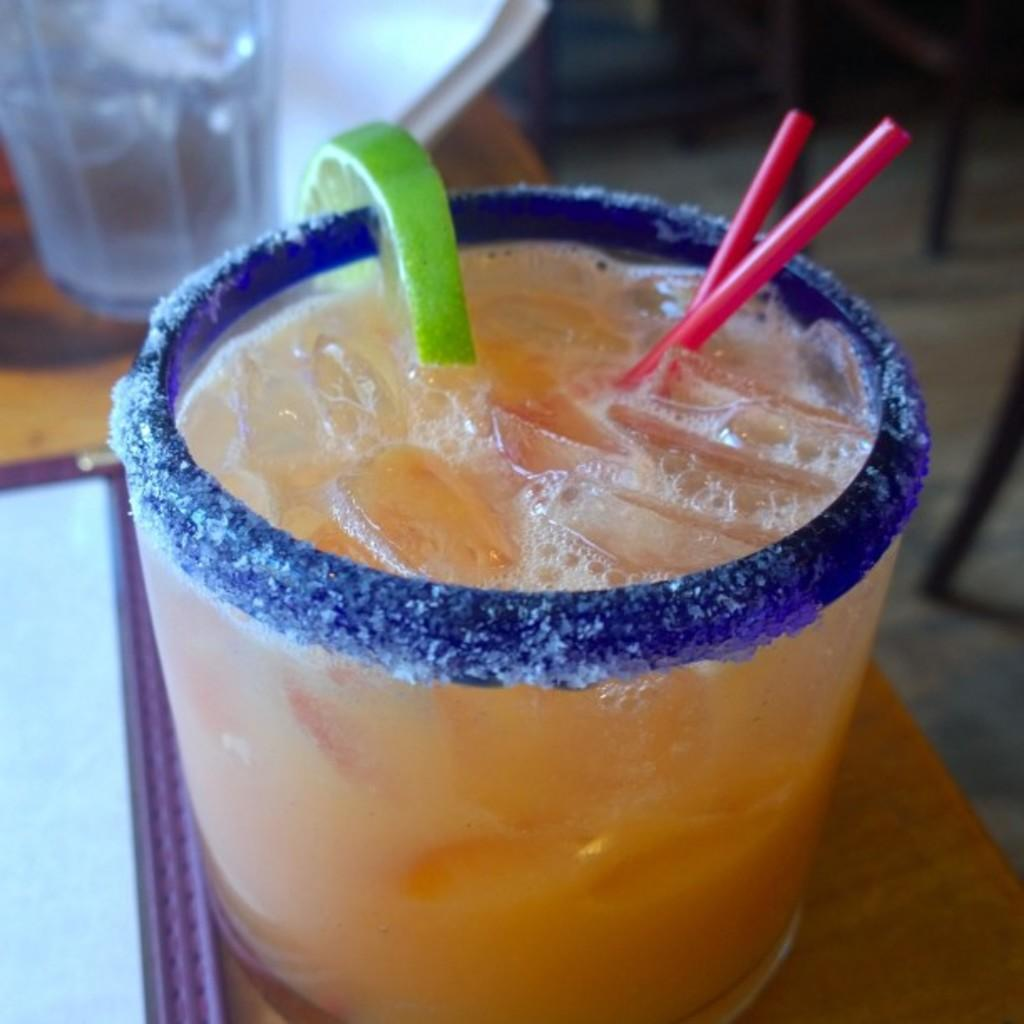What is in the glass that is visible in the image? There is a glass with juice in the image. What can be seen inside the glass? There are ice cubes, a lemon piece, and straws visible in the glass. Where is the glass placed in the image? The glass is placed on a table. What type of pan can be seen in the image? There is no pan present in the image. Can you hear any thunder in the image? There is no sound in the image, so it is impossible to determine if there is thunder. 